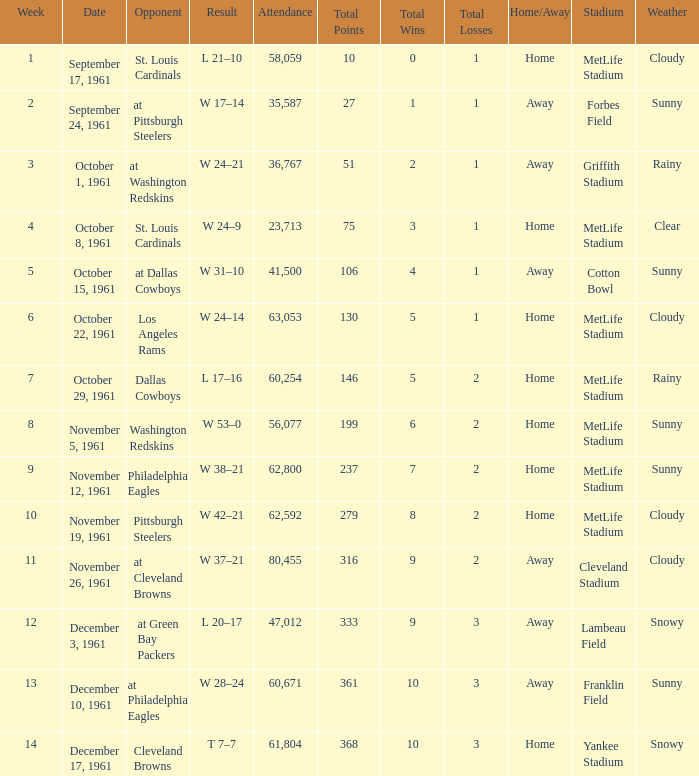Which Attendance has a Date of november 19, 1961? 62592.0. 